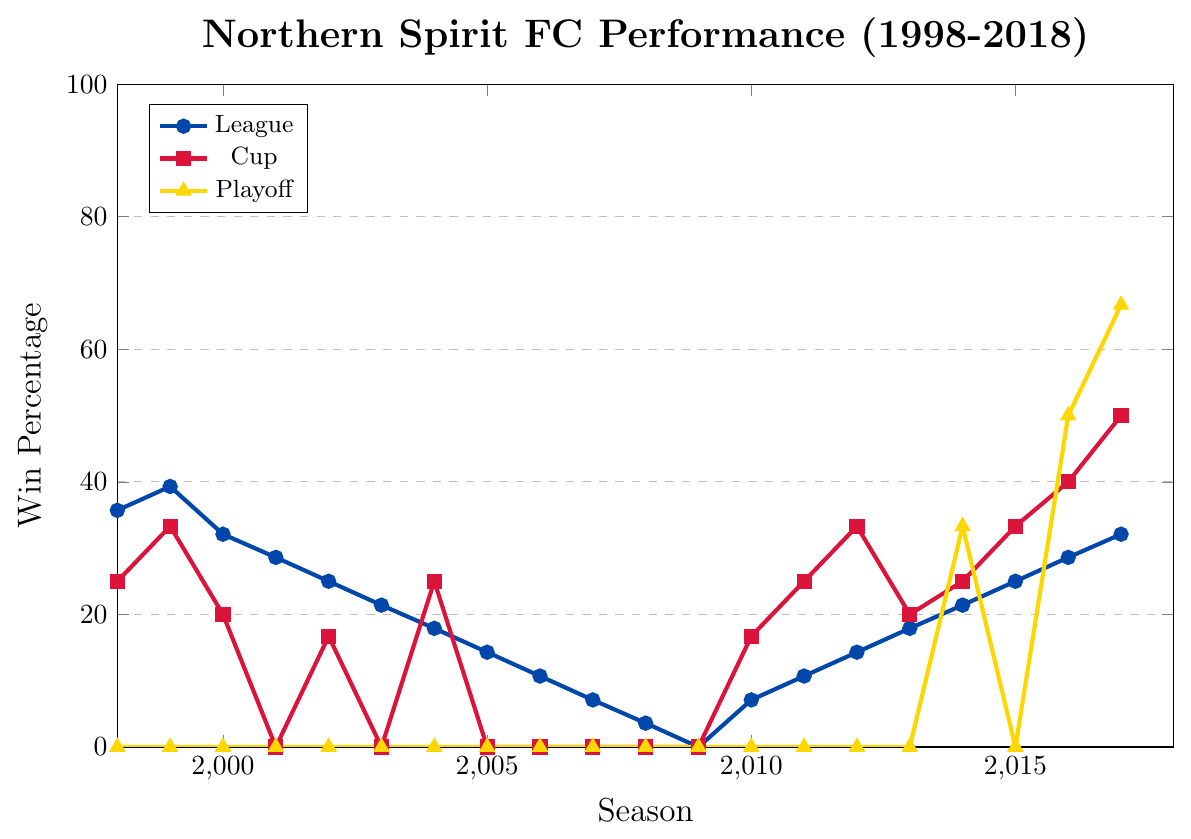What was Northern Spirit FC's overall trend in League win percentage from the 1998-99 to the 2017-18 season? To identify the overall trend, observe the general direction of the blue line representing the League win percentage. It starts at 35.7% in 1998-99, declines significantly until 2009-10 (0.0%), and then gradually increases, peaking at 32.1% in 2017-18.
Answer: Downward initially, then upward In which season did Northern Spirit FC have the highest Cup win percentage and what was it? To find this, look for the highest point on the red line representing Cup win percentage. The maximum value is at the 2017-18 season with a win percentage of 50.0%.
Answer: 2017-18, 50.0% Compare the League win percentage in the 1998-99 season to the 2009-10 season. Which one was greater? Locate the blue line at the 1998-99 season and 2009-10 season. In 1998-99, it was 35.7%, while in 2009-10, it was 0.0%.
Answer: 1998-99 When did Northern Spirit FC's Playoff win percentage first show a non-zero value? Trace the gold line for the first non-zero value. The Playoff win percentage first rises from 0.0% to 33.3% in the 2014-15 season.
Answer: 2014-15 Calculate the average League win percentage over the first three seasons (1998-99 to 2000-01). Add the League win percentages for the first three seasons and divide by 3: (35.7% + 39.3% + 32.1%) / 3.
Answer: 35.7% How much did the League win percentage change from the 2008-09 to the 2009-10 season? Subtract the League win percentage in 2008-09 (3.6%) from that in 2009-10 (0.0%).
Answer: -3.6% What was the win percentage in all competitions for the 2001-02 season? Look at all three lines for the 2001-02 season: League (28.6%), Cup (0.0%), Playoffs (0.0%).
Answer: 28.6%, 0.0%, 0.0% Which competition had the greatest win percentage improvement from 2015-16 to 2016-17? Compare the percentage change for each competition: League (25.0% to 28.6%), Cup (33.3% to 40.0%), Playoff (0.0% to 50.0%). Calculate the increases: League (3.6%), Cup (6.7%), Playoff (50.0%).
Answer: Playoff Identify the season in which the Cup win percentage was lowest, excluding seasons where it was zero. Find the lowest non-zero point on the red line: in the 2000-01 season, it was 20.0%.
Answer: 2000-01 What was the median Playoff win percentage between 1998-99 and 2017-18? List all Playoff win percentages (0.0%, 0.0%, ..., 66.7%), count the number of seasons (20), and find the middle values (10th and 11th): 0.0%, so the median is 0.0%.
Answer: 0.0% 